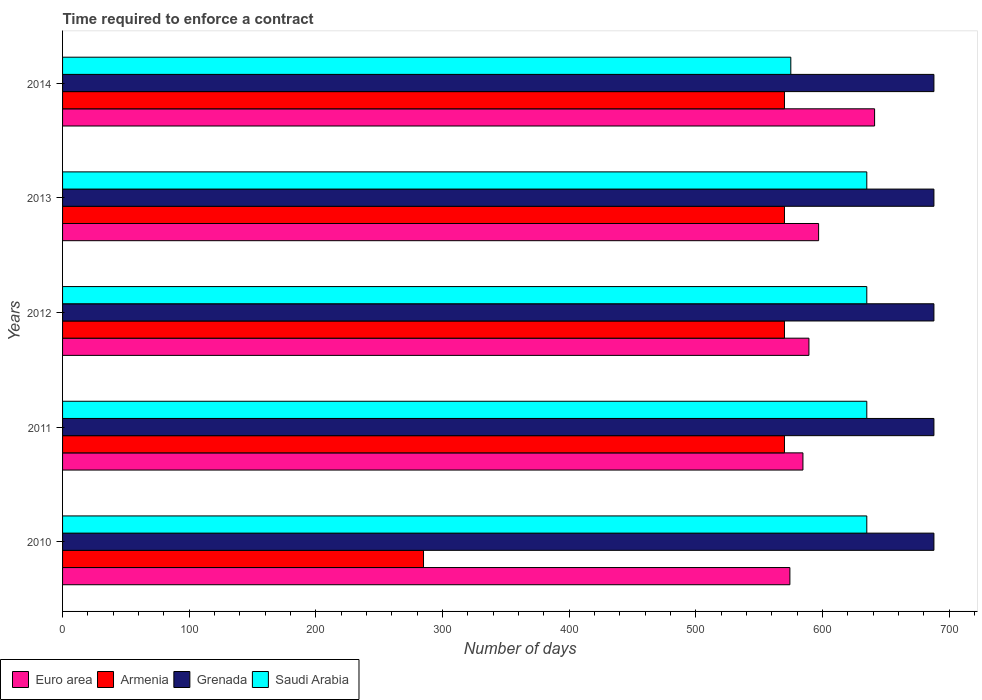Are the number of bars on each tick of the Y-axis equal?
Give a very brief answer. Yes. How many bars are there on the 2nd tick from the bottom?
Offer a terse response. 4. What is the label of the 4th group of bars from the top?
Your response must be concise. 2011. What is the number of days required to enforce a contract in Armenia in 2012?
Offer a terse response. 570. Across all years, what is the maximum number of days required to enforce a contract in Saudi Arabia?
Offer a very short reply. 635. Across all years, what is the minimum number of days required to enforce a contract in Euro area?
Provide a succinct answer. 574.28. In which year was the number of days required to enforce a contract in Armenia minimum?
Offer a very short reply. 2010. What is the total number of days required to enforce a contract in Armenia in the graph?
Ensure brevity in your answer.  2565. What is the difference between the number of days required to enforce a contract in Armenia in 2011 and that in 2014?
Your answer should be compact. 0. What is the difference between the number of days required to enforce a contract in Armenia in 2011 and the number of days required to enforce a contract in Saudi Arabia in 2012?
Provide a short and direct response. -65. What is the average number of days required to enforce a contract in Euro area per year?
Give a very brief answer. 597.26. In the year 2011, what is the difference between the number of days required to enforce a contract in Saudi Arabia and number of days required to enforce a contract in Euro area?
Your answer should be very brief. 50.42. In how many years, is the number of days required to enforce a contract in Grenada greater than 140 days?
Offer a very short reply. 5. What is the ratio of the number of days required to enforce a contract in Armenia in 2010 to that in 2013?
Provide a succinct answer. 0.5. Is the number of days required to enforce a contract in Armenia in 2010 less than that in 2014?
Offer a very short reply. Yes. Is the difference between the number of days required to enforce a contract in Saudi Arabia in 2011 and 2012 greater than the difference between the number of days required to enforce a contract in Euro area in 2011 and 2012?
Provide a succinct answer. Yes. What is the difference between the highest and the second highest number of days required to enforce a contract in Euro area?
Keep it short and to the point. 44.21. What is the difference between the highest and the lowest number of days required to enforce a contract in Grenada?
Offer a very short reply. 0. Is the sum of the number of days required to enforce a contract in Saudi Arabia in 2011 and 2014 greater than the maximum number of days required to enforce a contract in Grenada across all years?
Your answer should be compact. Yes. Is it the case that in every year, the sum of the number of days required to enforce a contract in Saudi Arabia and number of days required to enforce a contract in Euro area is greater than the sum of number of days required to enforce a contract in Grenada and number of days required to enforce a contract in Armenia?
Give a very brief answer. Yes. What does the 3rd bar from the top in 2011 represents?
Provide a succinct answer. Armenia. What does the 4th bar from the bottom in 2014 represents?
Your answer should be very brief. Saudi Arabia. Are all the bars in the graph horizontal?
Ensure brevity in your answer.  Yes. Are the values on the major ticks of X-axis written in scientific E-notation?
Give a very brief answer. No. Does the graph contain any zero values?
Your answer should be compact. No. Where does the legend appear in the graph?
Provide a succinct answer. Bottom left. How many legend labels are there?
Your answer should be very brief. 4. How are the legend labels stacked?
Your answer should be compact. Horizontal. What is the title of the graph?
Keep it short and to the point. Time required to enforce a contract. What is the label or title of the X-axis?
Give a very brief answer. Number of days. What is the label or title of the Y-axis?
Your answer should be compact. Years. What is the Number of days of Euro area in 2010?
Make the answer very short. 574.28. What is the Number of days in Armenia in 2010?
Keep it short and to the point. 285. What is the Number of days in Grenada in 2010?
Make the answer very short. 688. What is the Number of days of Saudi Arabia in 2010?
Make the answer very short. 635. What is the Number of days in Euro area in 2011?
Offer a terse response. 584.58. What is the Number of days of Armenia in 2011?
Provide a short and direct response. 570. What is the Number of days of Grenada in 2011?
Provide a short and direct response. 688. What is the Number of days in Saudi Arabia in 2011?
Ensure brevity in your answer.  635. What is the Number of days in Euro area in 2012?
Offer a terse response. 589.32. What is the Number of days of Armenia in 2012?
Ensure brevity in your answer.  570. What is the Number of days of Grenada in 2012?
Keep it short and to the point. 688. What is the Number of days in Saudi Arabia in 2012?
Provide a succinct answer. 635. What is the Number of days of Euro area in 2013?
Provide a short and direct response. 596.95. What is the Number of days of Armenia in 2013?
Provide a succinct answer. 570. What is the Number of days of Grenada in 2013?
Ensure brevity in your answer.  688. What is the Number of days in Saudi Arabia in 2013?
Offer a very short reply. 635. What is the Number of days of Euro area in 2014?
Your answer should be very brief. 641.16. What is the Number of days in Armenia in 2014?
Provide a short and direct response. 570. What is the Number of days in Grenada in 2014?
Provide a short and direct response. 688. What is the Number of days of Saudi Arabia in 2014?
Provide a succinct answer. 575. Across all years, what is the maximum Number of days in Euro area?
Your answer should be compact. 641.16. Across all years, what is the maximum Number of days in Armenia?
Provide a succinct answer. 570. Across all years, what is the maximum Number of days of Grenada?
Provide a succinct answer. 688. Across all years, what is the maximum Number of days of Saudi Arabia?
Your response must be concise. 635. Across all years, what is the minimum Number of days in Euro area?
Provide a short and direct response. 574.28. Across all years, what is the minimum Number of days of Armenia?
Provide a short and direct response. 285. Across all years, what is the minimum Number of days of Grenada?
Give a very brief answer. 688. Across all years, what is the minimum Number of days in Saudi Arabia?
Ensure brevity in your answer.  575. What is the total Number of days of Euro area in the graph?
Offer a terse response. 2986.28. What is the total Number of days in Armenia in the graph?
Offer a terse response. 2565. What is the total Number of days in Grenada in the graph?
Offer a very short reply. 3440. What is the total Number of days of Saudi Arabia in the graph?
Offer a terse response. 3115. What is the difference between the Number of days in Euro area in 2010 and that in 2011?
Provide a succinct answer. -10.3. What is the difference between the Number of days in Armenia in 2010 and that in 2011?
Provide a short and direct response. -285. What is the difference between the Number of days of Grenada in 2010 and that in 2011?
Provide a short and direct response. 0. What is the difference between the Number of days in Euro area in 2010 and that in 2012?
Give a very brief answer. -15.04. What is the difference between the Number of days in Armenia in 2010 and that in 2012?
Your answer should be compact. -285. What is the difference between the Number of days of Euro area in 2010 and that in 2013?
Your answer should be compact. -22.67. What is the difference between the Number of days in Armenia in 2010 and that in 2013?
Offer a terse response. -285. What is the difference between the Number of days in Saudi Arabia in 2010 and that in 2013?
Offer a very short reply. 0. What is the difference between the Number of days in Euro area in 2010 and that in 2014?
Ensure brevity in your answer.  -66.88. What is the difference between the Number of days in Armenia in 2010 and that in 2014?
Ensure brevity in your answer.  -285. What is the difference between the Number of days in Grenada in 2010 and that in 2014?
Ensure brevity in your answer.  0. What is the difference between the Number of days in Saudi Arabia in 2010 and that in 2014?
Your response must be concise. 60. What is the difference between the Number of days in Euro area in 2011 and that in 2012?
Provide a short and direct response. -4.74. What is the difference between the Number of days of Armenia in 2011 and that in 2012?
Your answer should be compact. 0. What is the difference between the Number of days in Euro area in 2011 and that in 2013?
Provide a succinct answer. -12.37. What is the difference between the Number of days in Grenada in 2011 and that in 2013?
Offer a very short reply. 0. What is the difference between the Number of days of Saudi Arabia in 2011 and that in 2013?
Offer a very short reply. 0. What is the difference between the Number of days in Euro area in 2011 and that in 2014?
Your response must be concise. -56.58. What is the difference between the Number of days in Armenia in 2011 and that in 2014?
Your response must be concise. 0. What is the difference between the Number of days in Grenada in 2011 and that in 2014?
Your answer should be very brief. 0. What is the difference between the Number of days in Saudi Arabia in 2011 and that in 2014?
Make the answer very short. 60. What is the difference between the Number of days of Euro area in 2012 and that in 2013?
Make the answer very short. -7.63. What is the difference between the Number of days of Armenia in 2012 and that in 2013?
Offer a very short reply. 0. What is the difference between the Number of days in Euro area in 2012 and that in 2014?
Offer a very short reply. -51.84. What is the difference between the Number of days of Euro area in 2013 and that in 2014?
Your answer should be very brief. -44.21. What is the difference between the Number of days of Grenada in 2013 and that in 2014?
Offer a terse response. 0. What is the difference between the Number of days in Saudi Arabia in 2013 and that in 2014?
Your response must be concise. 60. What is the difference between the Number of days of Euro area in 2010 and the Number of days of Armenia in 2011?
Keep it short and to the point. 4.28. What is the difference between the Number of days of Euro area in 2010 and the Number of days of Grenada in 2011?
Ensure brevity in your answer.  -113.72. What is the difference between the Number of days in Euro area in 2010 and the Number of days in Saudi Arabia in 2011?
Make the answer very short. -60.72. What is the difference between the Number of days of Armenia in 2010 and the Number of days of Grenada in 2011?
Provide a short and direct response. -403. What is the difference between the Number of days in Armenia in 2010 and the Number of days in Saudi Arabia in 2011?
Offer a terse response. -350. What is the difference between the Number of days of Grenada in 2010 and the Number of days of Saudi Arabia in 2011?
Ensure brevity in your answer.  53. What is the difference between the Number of days of Euro area in 2010 and the Number of days of Armenia in 2012?
Ensure brevity in your answer.  4.28. What is the difference between the Number of days of Euro area in 2010 and the Number of days of Grenada in 2012?
Provide a short and direct response. -113.72. What is the difference between the Number of days of Euro area in 2010 and the Number of days of Saudi Arabia in 2012?
Keep it short and to the point. -60.72. What is the difference between the Number of days in Armenia in 2010 and the Number of days in Grenada in 2012?
Give a very brief answer. -403. What is the difference between the Number of days of Armenia in 2010 and the Number of days of Saudi Arabia in 2012?
Make the answer very short. -350. What is the difference between the Number of days in Grenada in 2010 and the Number of days in Saudi Arabia in 2012?
Make the answer very short. 53. What is the difference between the Number of days of Euro area in 2010 and the Number of days of Armenia in 2013?
Provide a short and direct response. 4.28. What is the difference between the Number of days in Euro area in 2010 and the Number of days in Grenada in 2013?
Offer a very short reply. -113.72. What is the difference between the Number of days in Euro area in 2010 and the Number of days in Saudi Arabia in 2013?
Keep it short and to the point. -60.72. What is the difference between the Number of days in Armenia in 2010 and the Number of days in Grenada in 2013?
Offer a very short reply. -403. What is the difference between the Number of days in Armenia in 2010 and the Number of days in Saudi Arabia in 2013?
Your answer should be very brief. -350. What is the difference between the Number of days in Grenada in 2010 and the Number of days in Saudi Arabia in 2013?
Give a very brief answer. 53. What is the difference between the Number of days in Euro area in 2010 and the Number of days in Armenia in 2014?
Provide a short and direct response. 4.28. What is the difference between the Number of days of Euro area in 2010 and the Number of days of Grenada in 2014?
Give a very brief answer. -113.72. What is the difference between the Number of days in Euro area in 2010 and the Number of days in Saudi Arabia in 2014?
Your response must be concise. -0.72. What is the difference between the Number of days in Armenia in 2010 and the Number of days in Grenada in 2014?
Provide a short and direct response. -403. What is the difference between the Number of days of Armenia in 2010 and the Number of days of Saudi Arabia in 2014?
Your answer should be compact. -290. What is the difference between the Number of days of Grenada in 2010 and the Number of days of Saudi Arabia in 2014?
Offer a terse response. 113. What is the difference between the Number of days in Euro area in 2011 and the Number of days in Armenia in 2012?
Your response must be concise. 14.58. What is the difference between the Number of days of Euro area in 2011 and the Number of days of Grenada in 2012?
Your answer should be compact. -103.42. What is the difference between the Number of days of Euro area in 2011 and the Number of days of Saudi Arabia in 2012?
Your answer should be very brief. -50.42. What is the difference between the Number of days in Armenia in 2011 and the Number of days in Grenada in 2012?
Offer a terse response. -118. What is the difference between the Number of days of Armenia in 2011 and the Number of days of Saudi Arabia in 2012?
Give a very brief answer. -65. What is the difference between the Number of days of Grenada in 2011 and the Number of days of Saudi Arabia in 2012?
Provide a short and direct response. 53. What is the difference between the Number of days of Euro area in 2011 and the Number of days of Armenia in 2013?
Your answer should be very brief. 14.58. What is the difference between the Number of days of Euro area in 2011 and the Number of days of Grenada in 2013?
Provide a succinct answer. -103.42. What is the difference between the Number of days of Euro area in 2011 and the Number of days of Saudi Arabia in 2013?
Make the answer very short. -50.42. What is the difference between the Number of days in Armenia in 2011 and the Number of days in Grenada in 2013?
Your response must be concise. -118. What is the difference between the Number of days in Armenia in 2011 and the Number of days in Saudi Arabia in 2013?
Provide a short and direct response. -65. What is the difference between the Number of days of Euro area in 2011 and the Number of days of Armenia in 2014?
Give a very brief answer. 14.58. What is the difference between the Number of days of Euro area in 2011 and the Number of days of Grenada in 2014?
Ensure brevity in your answer.  -103.42. What is the difference between the Number of days in Euro area in 2011 and the Number of days in Saudi Arabia in 2014?
Offer a terse response. 9.58. What is the difference between the Number of days in Armenia in 2011 and the Number of days in Grenada in 2014?
Give a very brief answer. -118. What is the difference between the Number of days in Grenada in 2011 and the Number of days in Saudi Arabia in 2014?
Your response must be concise. 113. What is the difference between the Number of days of Euro area in 2012 and the Number of days of Armenia in 2013?
Ensure brevity in your answer.  19.32. What is the difference between the Number of days in Euro area in 2012 and the Number of days in Grenada in 2013?
Offer a very short reply. -98.68. What is the difference between the Number of days in Euro area in 2012 and the Number of days in Saudi Arabia in 2013?
Your answer should be very brief. -45.68. What is the difference between the Number of days of Armenia in 2012 and the Number of days of Grenada in 2013?
Provide a short and direct response. -118. What is the difference between the Number of days of Armenia in 2012 and the Number of days of Saudi Arabia in 2013?
Give a very brief answer. -65. What is the difference between the Number of days of Euro area in 2012 and the Number of days of Armenia in 2014?
Keep it short and to the point. 19.32. What is the difference between the Number of days in Euro area in 2012 and the Number of days in Grenada in 2014?
Keep it short and to the point. -98.68. What is the difference between the Number of days in Euro area in 2012 and the Number of days in Saudi Arabia in 2014?
Keep it short and to the point. 14.32. What is the difference between the Number of days in Armenia in 2012 and the Number of days in Grenada in 2014?
Provide a short and direct response. -118. What is the difference between the Number of days of Armenia in 2012 and the Number of days of Saudi Arabia in 2014?
Your answer should be compact. -5. What is the difference between the Number of days in Grenada in 2012 and the Number of days in Saudi Arabia in 2014?
Keep it short and to the point. 113. What is the difference between the Number of days in Euro area in 2013 and the Number of days in Armenia in 2014?
Make the answer very short. 26.95. What is the difference between the Number of days in Euro area in 2013 and the Number of days in Grenada in 2014?
Make the answer very short. -91.05. What is the difference between the Number of days in Euro area in 2013 and the Number of days in Saudi Arabia in 2014?
Keep it short and to the point. 21.95. What is the difference between the Number of days in Armenia in 2013 and the Number of days in Grenada in 2014?
Make the answer very short. -118. What is the difference between the Number of days of Grenada in 2013 and the Number of days of Saudi Arabia in 2014?
Provide a succinct answer. 113. What is the average Number of days in Euro area per year?
Offer a terse response. 597.26. What is the average Number of days of Armenia per year?
Your answer should be compact. 513. What is the average Number of days of Grenada per year?
Offer a terse response. 688. What is the average Number of days of Saudi Arabia per year?
Provide a short and direct response. 623. In the year 2010, what is the difference between the Number of days in Euro area and Number of days in Armenia?
Your response must be concise. 289.28. In the year 2010, what is the difference between the Number of days of Euro area and Number of days of Grenada?
Provide a short and direct response. -113.72. In the year 2010, what is the difference between the Number of days in Euro area and Number of days in Saudi Arabia?
Provide a succinct answer. -60.72. In the year 2010, what is the difference between the Number of days of Armenia and Number of days of Grenada?
Your response must be concise. -403. In the year 2010, what is the difference between the Number of days of Armenia and Number of days of Saudi Arabia?
Your answer should be very brief. -350. In the year 2010, what is the difference between the Number of days in Grenada and Number of days in Saudi Arabia?
Your answer should be compact. 53. In the year 2011, what is the difference between the Number of days in Euro area and Number of days in Armenia?
Give a very brief answer. 14.58. In the year 2011, what is the difference between the Number of days of Euro area and Number of days of Grenada?
Provide a short and direct response. -103.42. In the year 2011, what is the difference between the Number of days in Euro area and Number of days in Saudi Arabia?
Provide a short and direct response. -50.42. In the year 2011, what is the difference between the Number of days in Armenia and Number of days in Grenada?
Keep it short and to the point. -118. In the year 2011, what is the difference between the Number of days in Armenia and Number of days in Saudi Arabia?
Give a very brief answer. -65. In the year 2011, what is the difference between the Number of days in Grenada and Number of days in Saudi Arabia?
Offer a very short reply. 53. In the year 2012, what is the difference between the Number of days of Euro area and Number of days of Armenia?
Keep it short and to the point. 19.32. In the year 2012, what is the difference between the Number of days in Euro area and Number of days in Grenada?
Ensure brevity in your answer.  -98.68. In the year 2012, what is the difference between the Number of days in Euro area and Number of days in Saudi Arabia?
Your answer should be compact. -45.68. In the year 2012, what is the difference between the Number of days in Armenia and Number of days in Grenada?
Give a very brief answer. -118. In the year 2012, what is the difference between the Number of days of Armenia and Number of days of Saudi Arabia?
Make the answer very short. -65. In the year 2012, what is the difference between the Number of days of Grenada and Number of days of Saudi Arabia?
Keep it short and to the point. 53. In the year 2013, what is the difference between the Number of days in Euro area and Number of days in Armenia?
Make the answer very short. 26.95. In the year 2013, what is the difference between the Number of days in Euro area and Number of days in Grenada?
Offer a terse response. -91.05. In the year 2013, what is the difference between the Number of days in Euro area and Number of days in Saudi Arabia?
Keep it short and to the point. -38.05. In the year 2013, what is the difference between the Number of days of Armenia and Number of days of Grenada?
Offer a very short reply. -118. In the year 2013, what is the difference between the Number of days of Armenia and Number of days of Saudi Arabia?
Keep it short and to the point. -65. In the year 2014, what is the difference between the Number of days of Euro area and Number of days of Armenia?
Your answer should be very brief. 71.16. In the year 2014, what is the difference between the Number of days of Euro area and Number of days of Grenada?
Provide a succinct answer. -46.84. In the year 2014, what is the difference between the Number of days of Euro area and Number of days of Saudi Arabia?
Give a very brief answer. 66.16. In the year 2014, what is the difference between the Number of days of Armenia and Number of days of Grenada?
Make the answer very short. -118. In the year 2014, what is the difference between the Number of days of Armenia and Number of days of Saudi Arabia?
Ensure brevity in your answer.  -5. In the year 2014, what is the difference between the Number of days of Grenada and Number of days of Saudi Arabia?
Your answer should be very brief. 113. What is the ratio of the Number of days in Euro area in 2010 to that in 2011?
Provide a succinct answer. 0.98. What is the ratio of the Number of days in Saudi Arabia in 2010 to that in 2011?
Your answer should be very brief. 1. What is the ratio of the Number of days of Euro area in 2010 to that in 2012?
Keep it short and to the point. 0.97. What is the ratio of the Number of days of Armenia in 2010 to that in 2012?
Your response must be concise. 0.5. What is the ratio of the Number of days of Saudi Arabia in 2010 to that in 2012?
Offer a terse response. 1. What is the ratio of the Number of days in Euro area in 2010 to that in 2013?
Give a very brief answer. 0.96. What is the ratio of the Number of days of Saudi Arabia in 2010 to that in 2013?
Offer a terse response. 1. What is the ratio of the Number of days of Euro area in 2010 to that in 2014?
Provide a succinct answer. 0.9. What is the ratio of the Number of days of Grenada in 2010 to that in 2014?
Offer a very short reply. 1. What is the ratio of the Number of days in Saudi Arabia in 2010 to that in 2014?
Offer a very short reply. 1.1. What is the ratio of the Number of days in Euro area in 2011 to that in 2013?
Your response must be concise. 0.98. What is the ratio of the Number of days in Grenada in 2011 to that in 2013?
Provide a short and direct response. 1. What is the ratio of the Number of days in Saudi Arabia in 2011 to that in 2013?
Provide a short and direct response. 1. What is the ratio of the Number of days of Euro area in 2011 to that in 2014?
Offer a very short reply. 0.91. What is the ratio of the Number of days of Grenada in 2011 to that in 2014?
Keep it short and to the point. 1. What is the ratio of the Number of days in Saudi Arabia in 2011 to that in 2014?
Provide a succinct answer. 1.1. What is the ratio of the Number of days in Euro area in 2012 to that in 2013?
Make the answer very short. 0.99. What is the ratio of the Number of days of Armenia in 2012 to that in 2013?
Your answer should be very brief. 1. What is the ratio of the Number of days of Saudi Arabia in 2012 to that in 2013?
Offer a very short reply. 1. What is the ratio of the Number of days of Euro area in 2012 to that in 2014?
Ensure brevity in your answer.  0.92. What is the ratio of the Number of days in Saudi Arabia in 2012 to that in 2014?
Ensure brevity in your answer.  1.1. What is the ratio of the Number of days of Euro area in 2013 to that in 2014?
Offer a terse response. 0.93. What is the ratio of the Number of days of Grenada in 2013 to that in 2014?
Ensure brevity in your answer.  1. What is the ratio of the Number of days in Saudi Arabia in 2013 to that in 2014?
Your answer should be very brief. 1.1. What is the difference between the highest and the second highest Number of days of Euro area?
Provide a short and direct response. 44.21. What is the difference between the highest and the second highest Number of days of Grenada?
Offer a terse response. 0. What is the difference between the highest and the lowest Number of days in Euro area?
Your response must be concise. 66.88. What is the difference between the highest and the lowest Number of days in Armenia?
Your response must be concise. 285. What is the difference between the highest and the lowest Number of days of Grenada?
Keep it short and to the point. 0. 